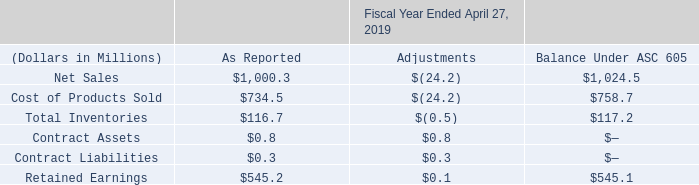2. Revenue
The Company is a global manufacturer of component and subsystem devices whose components are found in the primary end-markets of the aerospace, appliance, automotive, commercial vehicle, construction, consumer and industrial equipment, communications (including information processing and storage, networking equipment and wireless and terrestrial voice/data systems), medical, rail and other transportation industries. On April 29, 2018, the Company adopted ASC 606 along with the related amendments using a modified retrospective approach to all contracts open as of that date.
Upon adoption, the Company recognized a $0.1 million increase to opening retained earnings. This adjustment was a result of modifying the METHODE ELECTRONICS, INC. AND SUBSIDIARIES NOTES TO CONSOLIDATED FINANCIAL STATEMENTS F-14 Company's revenue recognition pattern for highly customized goods with no alternative use to over time recognition instead of point in time and for deferring revenue related to material rights that we provide to our customers. The overall impact to the Company's financial statements was immaterial. The Company has modified its controls to address the risks present under ASC 606.
As the Company has adopted ASC 606 using the modified retrospective approach, prior periods have not been restated, and as such they are presented under ASC 605. The impact of the changes in accounting policy on fiscal 2019 is provided below.
What is the retained earnings as reported in 2019?
Answer scale should be: million. $545.2. What was the increase in opening retained earnings post adoption? $0.1 million. What was the net sales as reported and under ASC 605 respectively?
Answer scale should be: million. 1,000.3, 1,024.5. What percentage of net sales was retained earnings as reported?
Answer scale should be: percent. 545.2 / 1,000.3
Answer: 54.5. What was the percentage of adjustment in cost of products sold as reported?
Answer scale should be: percent. 24.2 / 734.5
Answer: 3.29. What percentage of retained earnings was total inventories as reported?
Answer scale should be: percent. 116.7 / 545.2
Answer: 21.4. 